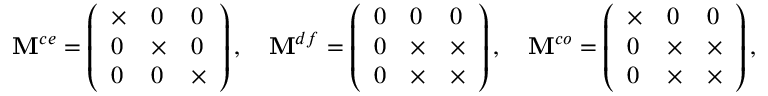Convert formula to latex. <formula><loc_0><loc_0><loc_500><loc_500>M ^ { c e } = \left ( \begin{array} { l l l } { \times } & { 0 } & { 0 } \\ { 0 } & { \times } & { 0 } \\ { 0 } & { 0 } & { \times } \end{array} \right ) , \quad M ^ { d f } = \left ( \begin{array} { l l l } { 0 } & { 0 } & { 0 } \\ { 0 } & { \times } & { \times } \\ { 0 } & { \times } & { \times } \end{array} \right ) , \quad M ^ { c o } = \left ( \begin{array} { l l l } { \times } & { 0 } & { 0 } \\ { 0 } & { \times } & { \times } \\ { 0 } & { \times } & { \times } \end{array} \right ) ,</formula> 